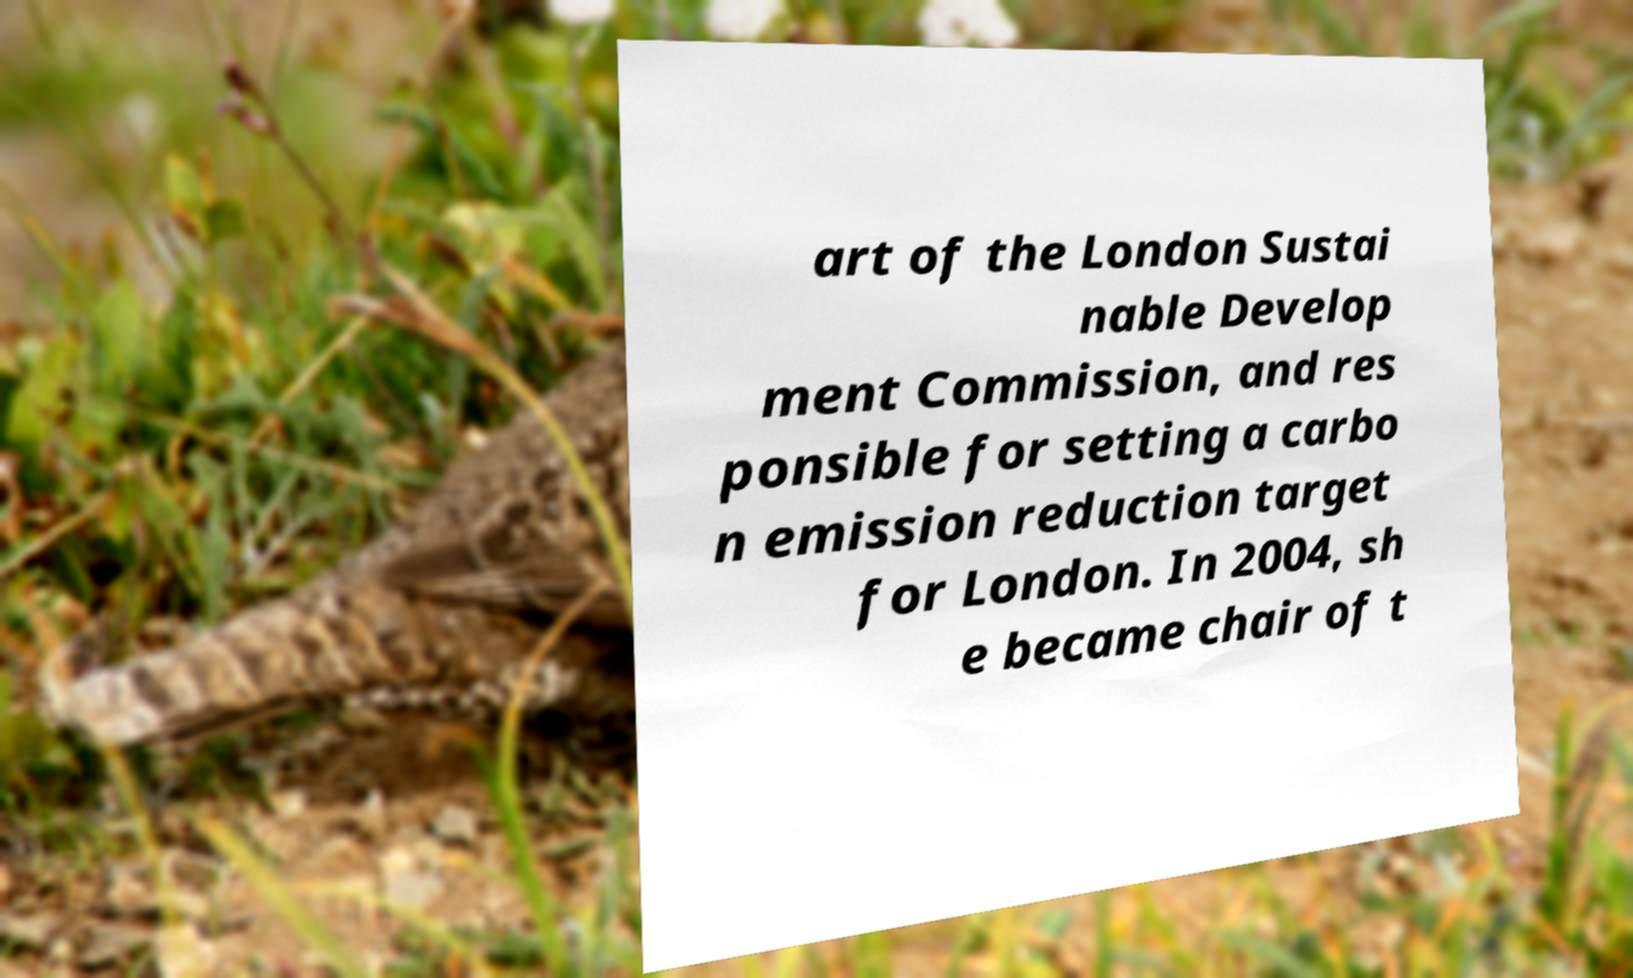What messages or text are displayed in this image? I need them in a readable, typed format. art of the London Sustai nable Develop ment Commission, and res ponsible for setting a carbo n emission reduction target for London. In 2004, sh e became chair of t 